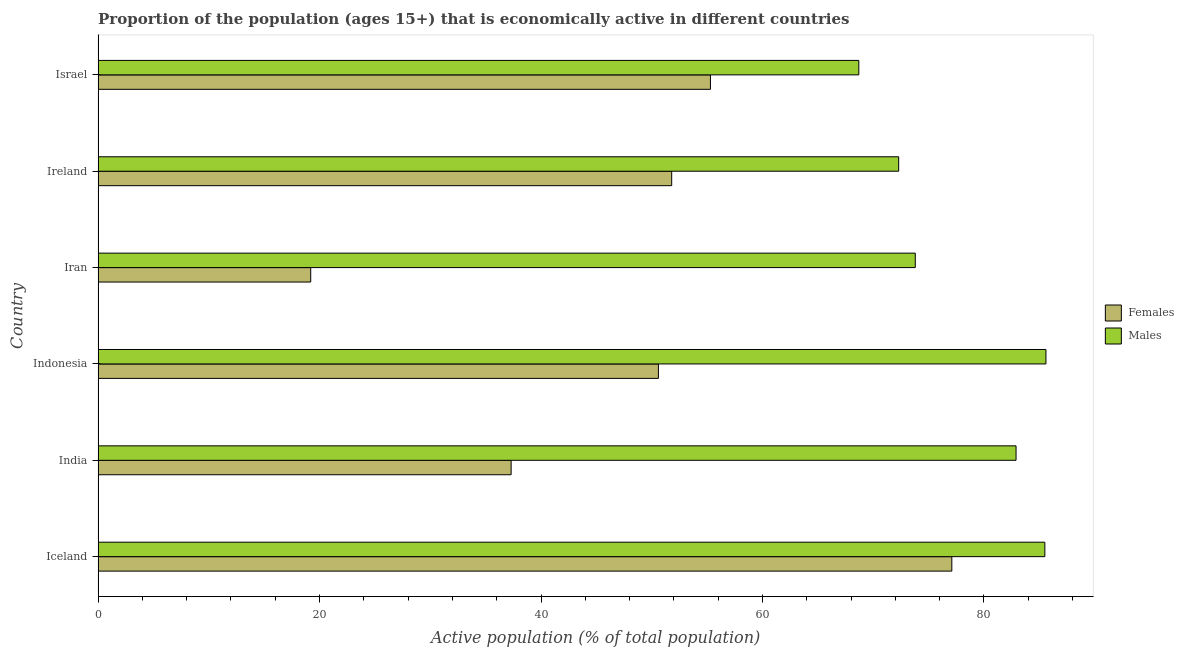How many groups of bars are there?
Your response must be concise. 6. Are the number of bars per tick equal to the number of legend labels?
Make the answer very short. Yes. How many bars are there on the 4th tick from the top?
Make the answer very short. 2. What is the label of the 1st group of bars from the top?
Provide a short and direct response. Israel. In how many cases, is the number of bars for a given country not equal to the number of legend labels?
Offer a very short reply. 0. What is the percentage of economically active male population in Israel?
Your answer should be very brief. 68.7. Across all countries, what is the maximum percentage of economically active female population?
Ensure brevity in your answer.  77.1. Across all countries, what is the minimum percentage of economically active female population?
Offer a terse response. 19.2. In which country was the percentage of economically active male population maximum?
Your response must be concise. Indonesia. In which country was the percentage of economically active female population minimum?
Give a very brief answer. Iran. What is the total percentage of economically active male population in the graph?
Provide a succinct answer. 468.8. What is the difference between the percentage of economically active female population in Iceland and that in Iran?
Your answer should be compact. 57.9. What is the difference between the percentage of economically active male population in Iceland and the percentage of economically active female population in India?
Offer a terse response. 48.2. What is the average percentage of economically active male population per country?
Offer a terse response. 78.13. In how many countries, is the percentage of economically active male population greater than 72 %?
Give a very brief answer. 5. Is the percentage of economically active male population in Iceland less than that in Israel?
Ensure brevity in your answer.  No. What is the difference between the highest and the second highest percentage of economically active female population?
Make the answer very short. 21.8. Is the sum of the percentage of economically active female population in India and Iran greater than the maximum percentage of economically active male population across all countries?
Provide a short and direct response. No. What does the 1st bar from the top in Iceland represents?
Give a very brief answer. Males. What does the 1st bar from the bottom in Israel represents?
Offer a terse response. Females. How many bars are there?
Your response must be concise. 12. What is the difference between two consecutive major ticks on the X-axis?
Offer a terse response. 20. Does the graph contain grids?
Provide a succinct answer. No. How many legend labels are there?
Your response must be concise. 2. What is the title of the graph?
Provide a short and direct response. Proportion of the population (ages 15+) that is economically active in different countries. Does "Fertility rate" appear as one of the legend labels in the graph?
Ensure brevity in your answer.  No. What is the label or title of the X-axis?
Your response must be concise. Active population (% of total population). What is the label or title of the Y-axis?
Offer a very short reply. Country. What is the Active population (% of total population) in Females in Iceland?
Your response must be concise. 77.1. What is the Active population (% of total population) of Males in Iceland?
Give a very brief answer. 85.5. What is the Active population (% of total population) of Females in India?
Ensure brevity in your answer.  37.3. What is the Active population (% of total population) in Males in India?
Your answer should be compact. 82.9. What is the Active population (% of total population) in Females in Indonesia?
Your answer should be very brief. 50.6. What is the Active population (% of total population) in Males in Indonesia?
Give a very brief answer. 85.6. What is the Active population (% of total population) of Females in Iran?
Offer a terse response. 19.2. What is the Active population (% of total population) of Males in Iran?
Provide a succinct answer. 73.8. What is the Active population (% of total population) in Females in Ireland?
Your response must be concise. 51.8. What is the Active population (% of total population) of Males in Ireland?
Offer a terse response. 72.3. What is the Active population (% of total population) in Females in Israel?
Your answer should be very brief. 55.3. What is the Active population (% of total population) of Males in Israel?
Offer a very short reply. 68.7. Across all countries, what is the maximum Active population (% of total population) of Females?
Provide a succinct answer. 77.1. Across all countries, what is the maximum Active population (% of total population) of Males?
Keep it short and to the point. 85.6. Across all countries, what is the minimum Active population (% of total population) of Females?
Ensure brevity in your answer.  19.2. Across all countries, what is the minimum Active population (% of total population) in Males?
Your answer should be compact. 68.7. What is the total Active population (% of total population) in Females in the graph?
Provide a succinct answer. 291.3. What is the total Active population (% of total population) in Males in the graph?
Offer a very short reply. 468.8. What is the difference between the Active population (% of total population) of Females in Iceland and that in India?
Your answer should be compact. 39.8. What is the difference between the Active population (% of total population) of Males in Iceland and that in India?
Your answer should be compact. 2.6. What is the difference between the Active population (% of total population) in Males in Iceland and that in Indonesia?
Your answer should be compact. -0.1. What is the difference between the Active population (% of total population) of Females in Iceland and that in Iran?
Provide a succinct answer. 57.9. What is the difference between the Active population (% of total population) of Females in Iceland and that in Ireland?
Your answer should be very brief. 25.3. What is the difference between the Active population (% of total population) in Females in Iceland and that in Israel?
Provide a succinct answer. 21.8. What is the difference between the Active population (% of total population) of Females in India and that in Indonesia?
Offer a terse response. -13.3. What is the difference between the Active population (% of total population) of Females in India and that in Iran?
Offer a very short reply. 18.1. What is the difference between the Active population (% of total population) of Females in India and that in Ireland?
Keep it short and to the point. -14.5. What is the difference between the Active population (% of total population) of Males in India and that in Ireland?
Offer a very short reply. 10.6. What is the difference between the Active population (% of total population) in Females in Indonesia and that in Iran?
Provide a succinct answer. 31.4. What is the difference between the Active population (% of total population) of Females in Iran and that in Ireland?
Provide a short and direct response. -32.6. What is the difference between the Active population (% of total population) of Females in Iran and that in Israel?
Ensure brevity in your answer.  -36.1. What is the difference between the Active population (% of total population) in Females in Ireland and that in Israel?
Provide a short and direct response. -3.5. What is the difference between the Active population (% of total population) in Males in Ireland and that in Israel?
Your answer should be compact. 3.6. What is the difference between the Active population (% of total population) in Females in Iceland and the Active population (% of total population) in Males in Iran?
Give a very brief answer. 3.3. What is the difference between the Active population (% of total population) in Females in India and the Active population (% of total population) in Males in Indonesia?
Your response must be concise. -48.3. What is the difference between the Active population (% of total population) in Females in India and the Active population (% of total population) in Males in Iran?
Give a very brief answer. -36.5. What is the difference between the Active population (% of total population) in Females in India and the Active population (% of total population) in Males in Ireland?
Offer a very short reply. -35. What is the difference between the Active population (% of total population) of Females in India and the Active population (% of total population) of Males in Israel?
Make the answer very short. -31.4. What is the difference between the Active population (% of total population) in Females in Indonesia and the Active population (% of total population) in Males in Iran?
Your answer should be very brief. -23.2. What is the difference between the Active population (% of total population) in Females in Indonesia and the Active population (% of total population) in Males in Ireland?
Offer a terse response. -21.7. What is the difference between the Active population (% of total population) of Females in Indonesia and the Active population (% of total population) of Males in Israel?
Your response must be concise. -18.1. What is the difference between the Active population (% of total population) in Females in Iran and the Active population (% of total population) in Males in Ireland?
Offer a terse response. -53.1. What is the difference between the Active population (% of total population) of Females in Iran and the Active population (% of total population) of Males in Israel?
Give a very brief answer. -49.5. What is the difference between the Active population (% of total population) in Females in Ireland and the Active population (% of total population) in Males in Israel?
Your answer should be compact. -16.9. What is the average Active population (% of total population) of Females per country?
Offer a terse response. 48.55. What is the average Active population (% of total population) in Males per country?
Your answer should be compact. 78.13. What is the difference between the Active population (% of total population) in Females and Active population (% of total population) in Males in India?
Keep it short and to the point. -45.6. What is the difference between the Active population (% of total population) of Females and Active population (% of total population) of Males in Indonesia?
Keep it short and to the point. -35. What is the difference between the Active population (% of total population) in Females and Active population (% of total population) in Males in Iran?
Your answer should be very brief. -54.6. What is the difference between the Active population (% of total population) of Females and Active population (% of total population) of Males in Ireland?
Keep it short and to the point. -20.5. What is the difference between the Active population (% of total population) of Females and Active population (% of total population) of Males in Israel?
Provide a short and direct response. -13.4. What is the ratio of the Active population (% of total population) of Females in Iceland to that in India?
Ensure brevity in your answer.  2.07. What is the ratio of the Active population (% of total population) in Males in Iceland to that in India?
Offer a very short reply. 1.03. What is the ratio of the Active population (% of total population) of Females in Iceland to that in Indonesia?
Provide a succinct answer. 1.52. What is the ratio of the Active population (% of total population) of Males in Iceland to that in Indonesia?
Provide a short and direct response. 1. What is the ratio of the Active population (% of total population) of Females in Iceland to that in Iran?
Provide a short and direct response. 4.02. What is the ratio of the Active population (% of total population) of Males in Iceland to that in Iran?
Keep it short and to the point. 1.16. What is the ratio of the Active population (% of total population) of Females in Iceland to that in Ireland?
Keep it short and to the point. 1.49. What is the ratio of the Active population (% of total population) in Males in Iceland to that in Ireland?
Give a very brief answer. 1.18. What is the ratio of the Active population (% of total population) of Females in Iceland to that in Israel?
Keep it short and to the point. 1.39. What is the ratio of the Active population (% of total population) of Males in Iceland to that in Israel?
Provide a succinct answer. 1.24. What is the ratio of the Active population (% of total population) in Females in India to that in Indonesia?
Ensure brevity in your answer.  0.74. What is the ratio of the Active population (% of total population) in Males in India to that in Indonesia?
Your answer should be compact. 0.97. What is the ratio of the Active population (% of total population) in Females in India to that in Iran?
Provide a succinct answer. 1.94. What is the ratio of the Active population (% of total population) of Males in India to that in Iran?
Offer a terse response. 1.12. What is the ratio of the Active population (% of total population) in Females in India to that in Ireland?
Offer a terse response. 0.72. What is the ratio of the Active population (% of total population) of Males in India to that in Ireland?
Provide a short and direct response. 1.15. What is the ratio of the Active population (% of total population) in Females in India to that in Israel?
Your answer should be compact. 0.67. What is the ratio of the Active population (% of total population) of Males in India to that in Israel?
Offer a very short reply. 1.21. What is the ratio of the Active population (% of total population) of Females in Indonesia to that in Iran?
Your answer should be very brief. 2.64. What is the ratio of the Active population (% of total population) in Males in Indonesia to that in Iran?
Ensure brevity in your answer.  1.16. What is the ratio of the Active population (% of total population) in Females in Indonesia to that in Ireland?
Your answer should be very brief. 0.98. What is the ratio of the Active population (% of total population) of Males in Indonesia to that in Ireland?
Provide a succinct answer. 1.18. What is the ratio of the Active population (% of total population) in Females in Indonesia to that in Israel?
Provide a short and direct response. 0.92. What is the ratio of the Active population (% of total population) of Males in Indonesia to that in Israel?
Offer a very short reply. 1.25. What is the ratio of the Active population (% of total population) of Females in Iran to that in Ireland?
Offer a terse response. 0.37. What is the ratio of the Active population (% of total population) in Males in Iran to that in Ireland?
Ensure brevity in your answer.  1.02. What is the ratio of the Active population (% of total population) of Females in Iran to that in Israel?
Ensure brevity in your answer.  0.35. What is the ratio of the Active population (% of total population) of Males in Iran to that in Israel?
Your response must be concise. 1.07. What is the ratio of the Active population (% of total population) of Females in Ireland to that in Israel?
Your answer should be very brief. 0.94. What is the ratio of the Active population (% of total population) in Males in Ireland to that in Israel?
Keep it short and to the point. 1.05. What is the difference between the highest and the second highest Active population (% of total population) of Females?
Your answer should be compact. 21.8. What is the difference between the highest and the lowest Active population (% of total population) in Females?
Provide a short and direct response. 57.9. 